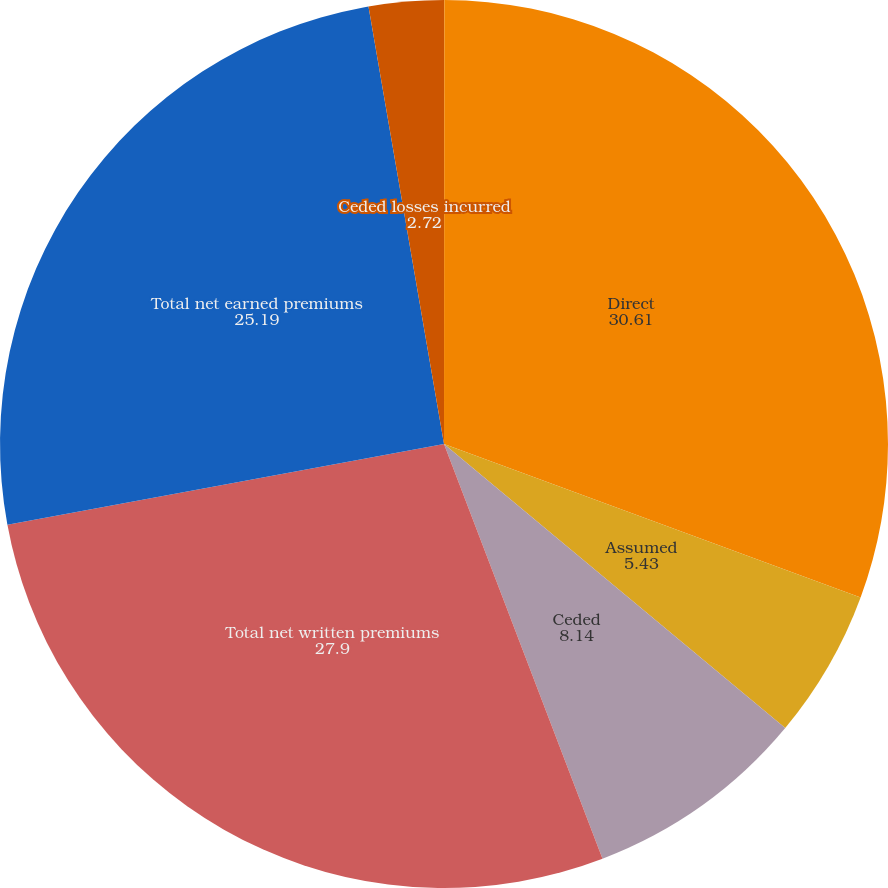Convert chart to OTSL. <chart><loc_0><loc_0><loc_500><loc_500><pie_chart><fcel>(In thousands)<fcel>Direct<fcel>Assumed<fcel>Ceded<fcel>Total net written premiums<fcel>Total net earned premiums<fcel>Ceded losses incurred<nl><fcel>0.01%<fcel>30.61%<fcel>5.43%<fcel>8.14%<fcel>27.9%<fcel>25.19%<fcel>2.72%<nl></chart> 